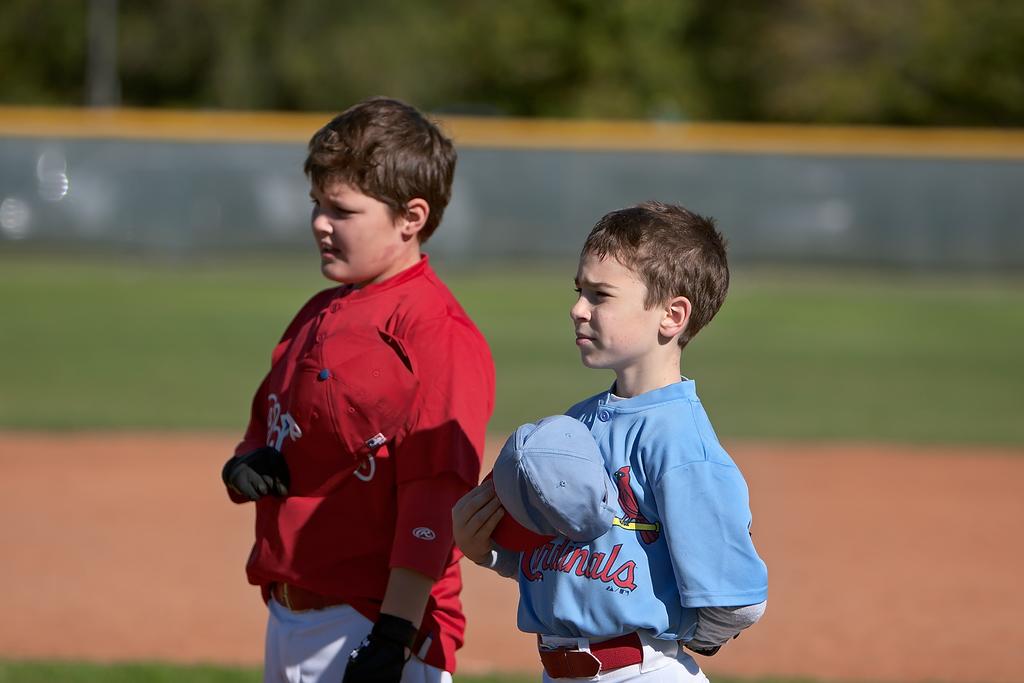Which team does the boy in blue play for?
Ensure brevity in your answer.  Cardinals. 